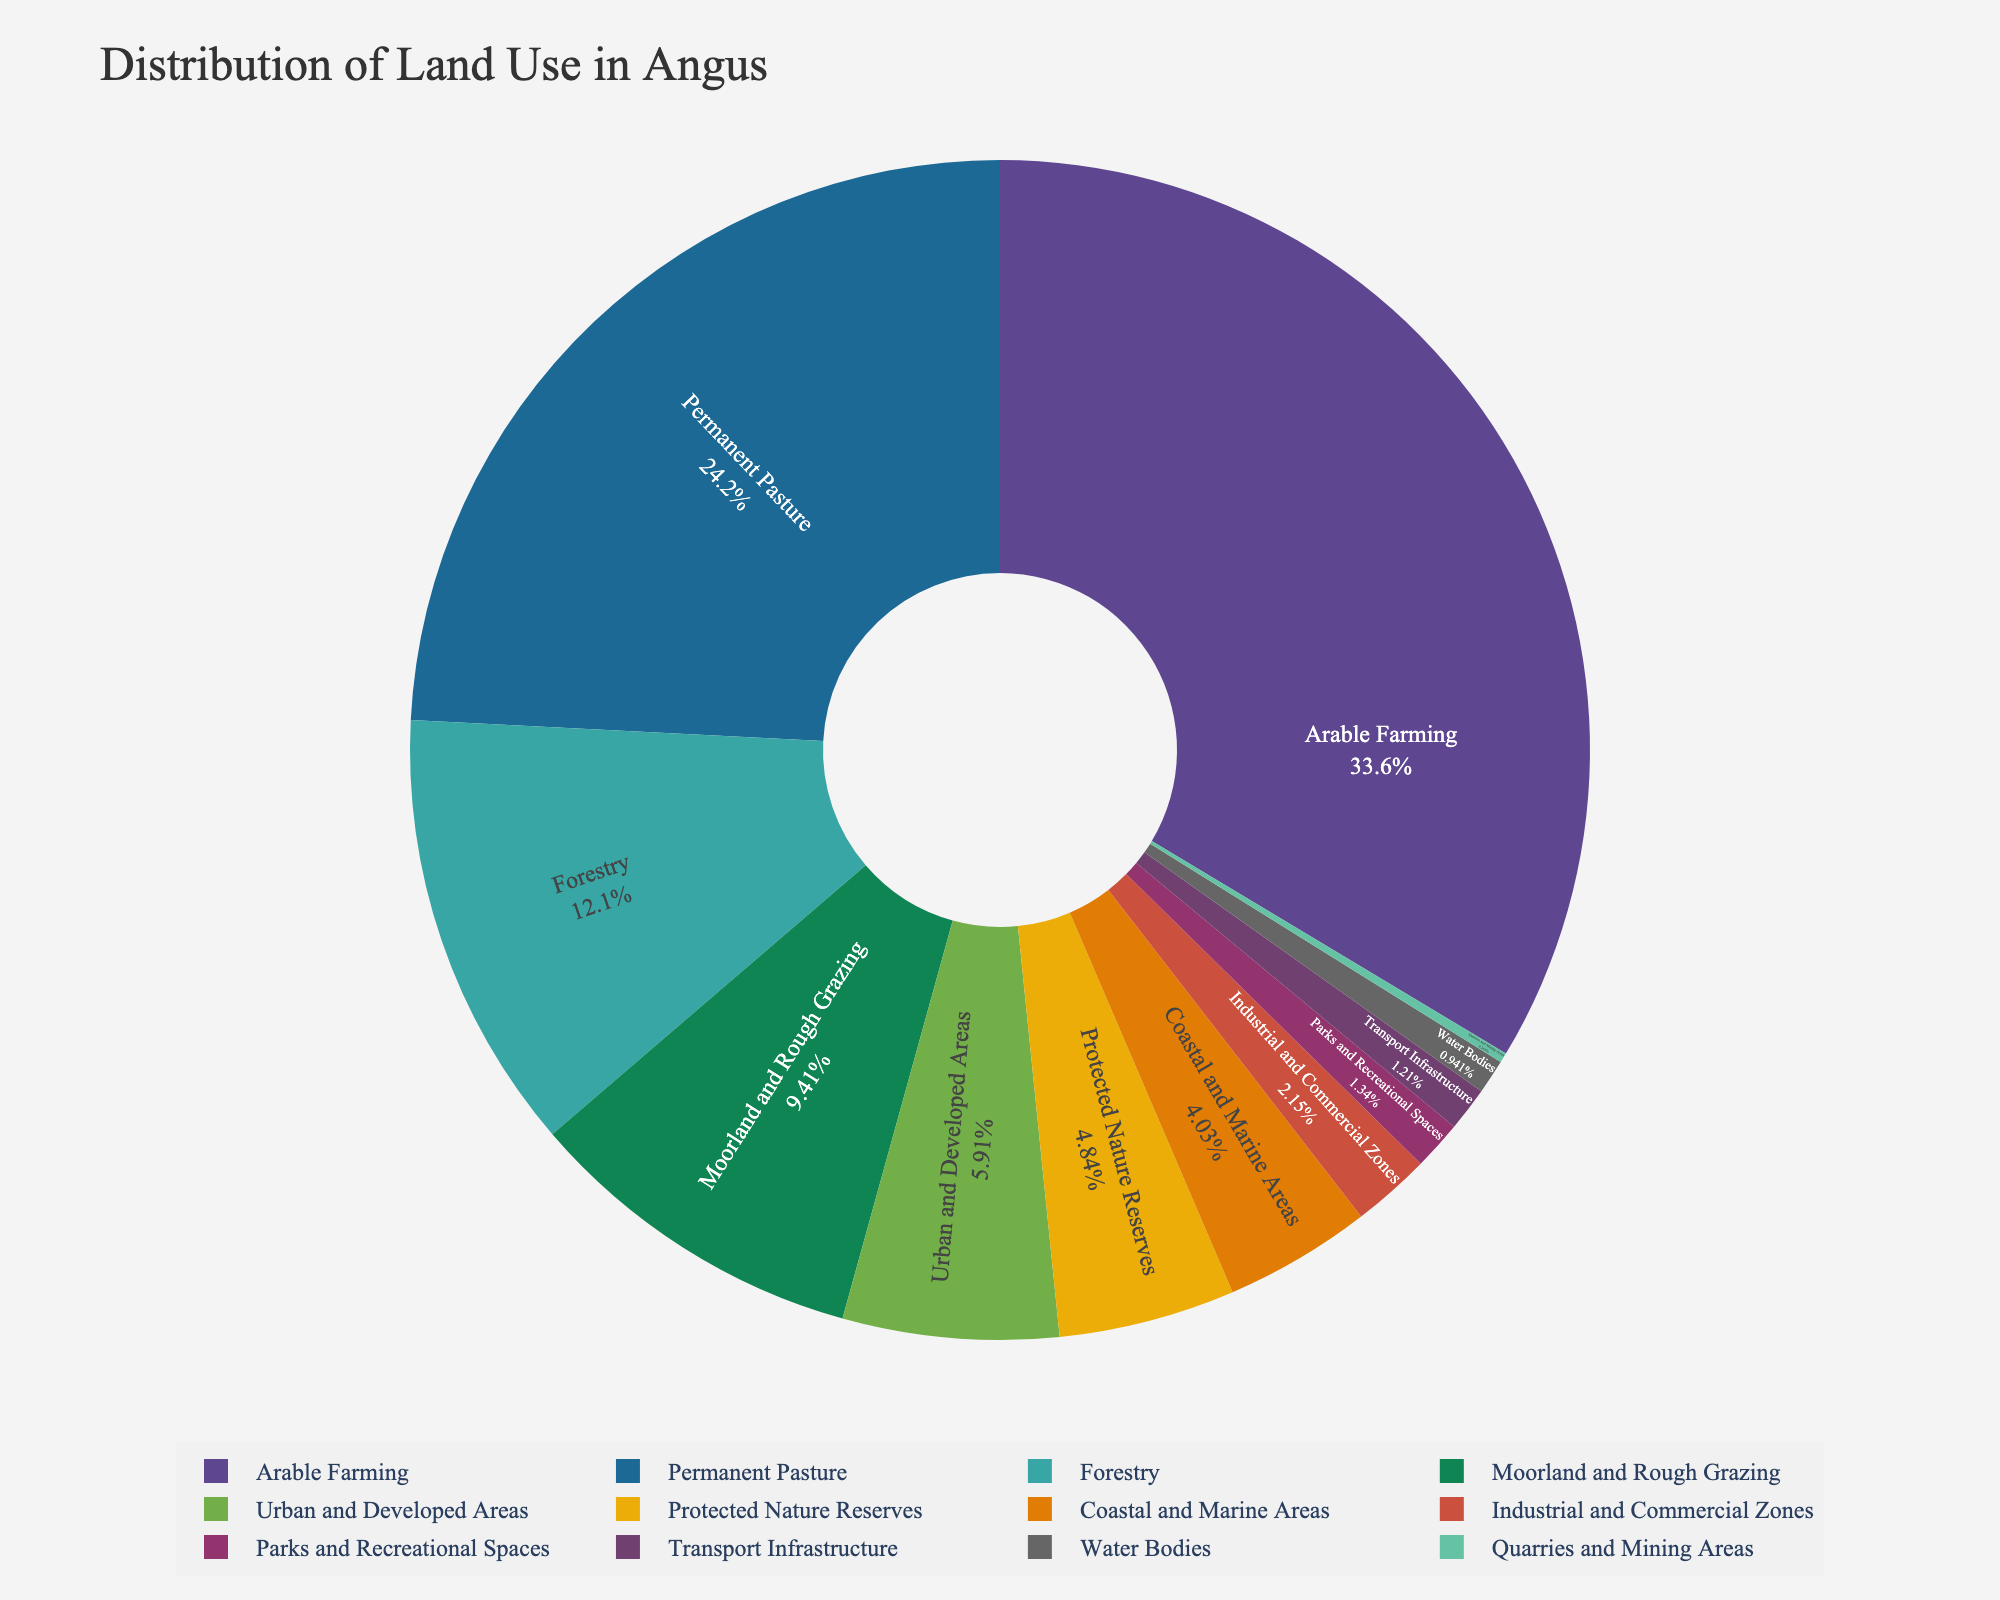What's the largest land use category in Angus? To answer this, observe the pie chart and identify the sector with the highest percentage. The chart should clearly show that "Arable Farming" occupies the largest portion.
Answer: Arable Farming Which land use category has a larger area: Urban and Developed Areas or Industrial and Commercial Zones? Compare the sizes of the sectors labeled "Urban and Developed Areas" and "Industrial and Commercial Zones" in the pie chart. "Urban and Developed Areas" has a larger sector compared to "Industrial and Commercial Zones".
Answer: Urban and Developed Areas What is the combined area of Permanent Pasture and Moorland and Rough Grazing? Look at the chart to find the percentages for "Permanent Pasture" and "Moorland and Rough Grazing". Add these percentages and convert them into actual areas based on provided dataset: 90,000 hectares (Permanent Pasture) + 35,000 hectares (Moorland and Rough Grazing) = 125,000 hectares.
Answer: 125,000 Which segment represents the smallest land use category? Identify the smallest sector in the pie chart which corresponds to "Quarries and Mining Areas".
Answer: Quarries and Mining Areas How does the area of Protected Nature Reserves compare to that of Coastal and Marine Areas? Check the sizes of the sectors for "Protected Nature Reserves" and "Coastal and Marine Areas" in the pie chart. "Protected Nature Reserves" appears larger.
Answer: Protected Nature Reserves What percentage of the total land does Transport Infrastructure occupy? Read from the pie chart the percentage associated with the "Transport Infrastructure" category.
Answer: 1.1% Which categories have areas less than 10,000 hectares? Identify sectors in the pie chart representing areas of less than 10,000 hectares: "Parks and Recreational Spaces", "Industrial and Commercial Zones", "Transport Infrastructure", "Water Bodies", "Quarries and Mining Areas".
Answer: Parks and Recreational Spaces, Industrial and Commercial Zones, Transport Infrastructure, Water Bodies, Quarries and Mining Areas If the sum of Urban and Developed Areas, Industrial and Commercial Zones, and Transport Infrastructure were to be reclassified as a single category, what would be the total hectares? Add the areas from the dataset: 22,000 hectares (Urban and Developed Areas) + 8,000 hectares (Industrial and Commercial Zones) + 4,500 hectares (Transport Infrastructure) = 34,500 hectares.
Answer: 34,500 Is the area dedicated to Forestry greater than the area dedicated to Moorland and Rough Grazing? Compare the sizes of the "Forestry" and "Moorland and Rough Grazing" sectors in the pie chart. The area for "Forestry" is 45,000 hectares and the area for "Moorland and Rough Grazing" is 35,000 hectares; hence, Forestry is greater.
Answer: Yes 